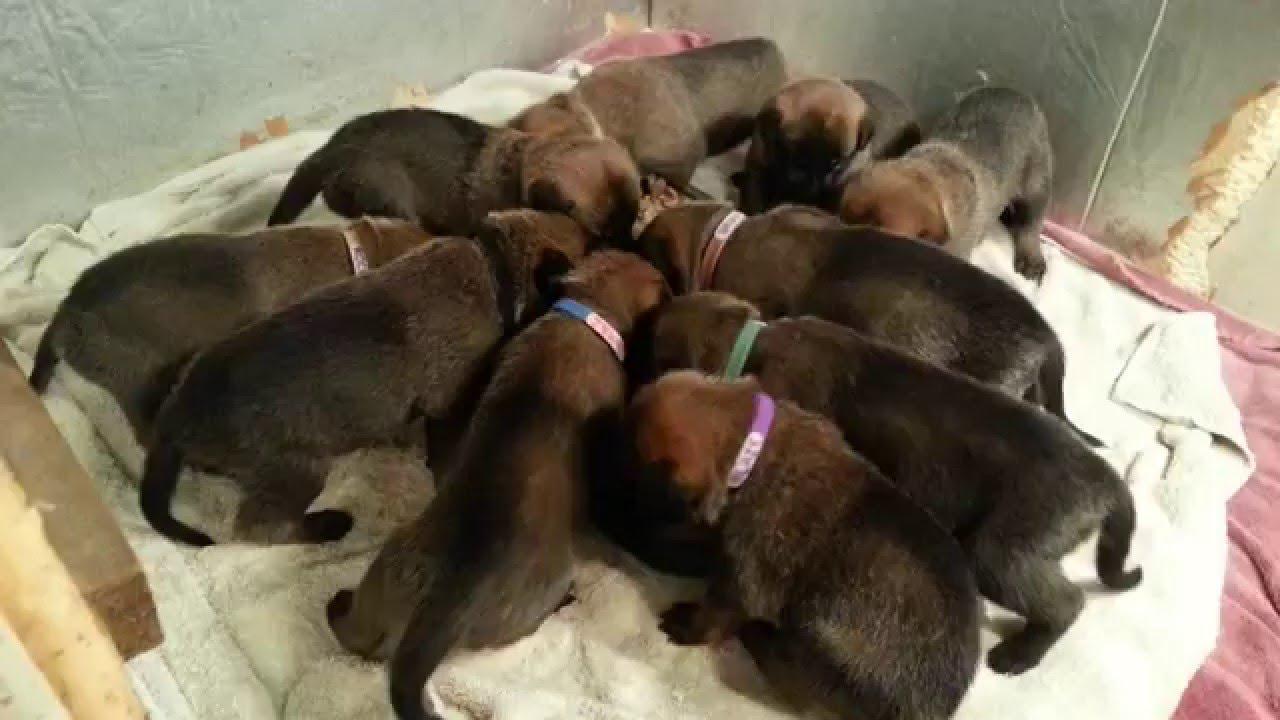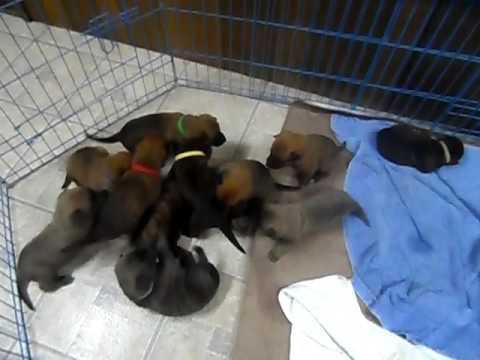The first image is the image on the left, the second image is the image on the right. Given the left and right images, does the statement "The puppies in at least one of the images are in a wired cage." hold true? Answer yes or no. Yes. The first image is the image on the left, the second image is the image on the right. For the images shown, is this caption "Each image shows a pile of puppies, and at least one pile of puppies is surrounded by a wire enclosure." true? Answer yes or no. Yes. 